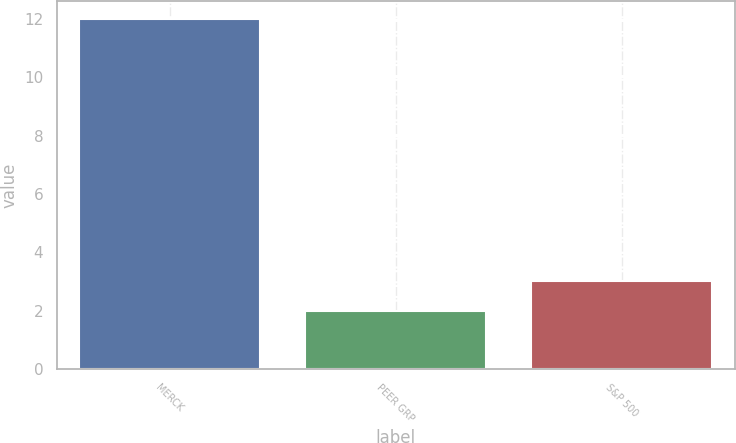Convert chart to OTSL. <chart><loc_0><loc_0><loc_500><loc_500><bar_chart><fcel>MERCK<fcel>PEER GRP<fcel>S&P 500<nl><fcel>12<fcel>2<fcel>3<nl></chart> 